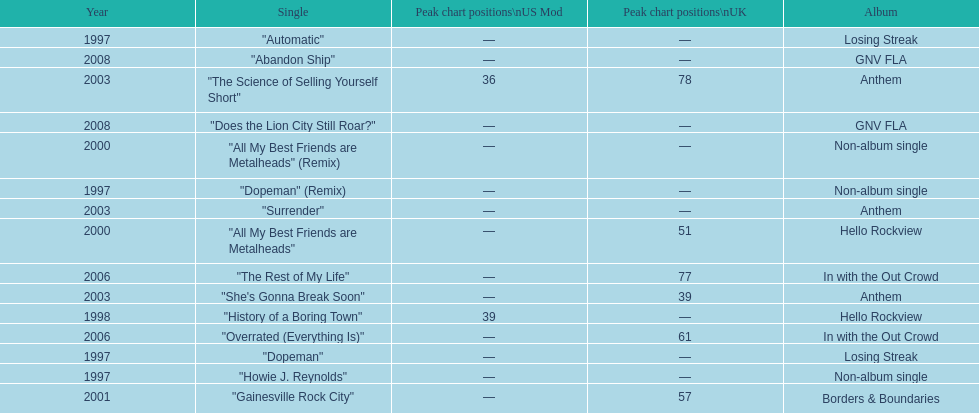What was the next single after "overrated (everything is)"? "The Rest of My Life". 